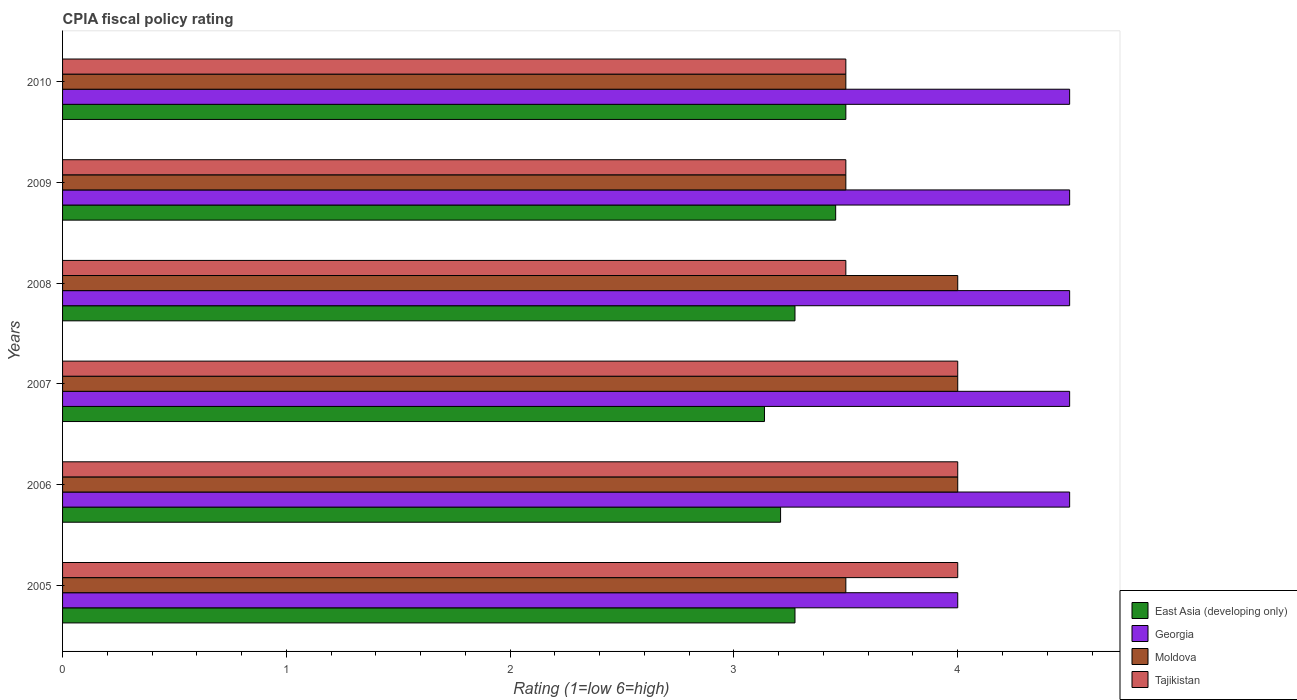Are the number of bars per tick equal to the number of legend labels?
Offer a very short reply. Yes. What is the CPIA rating in Moldova in 2010?
Offer a very short reply. 3.5. In which year was the CPIA rating in Tajikistan maximum?
Your answer should be compact. 2005. In which year was the CPIA rating in Georgia minimum?
Provide a short and direct response. 2005. What is the difference between the CPIA rating in Georgia in 2007 and that in 2010?
Offer a very short reply. 0. What is the average CPIA rating in Moldova per year?
Ensure brevity in your answer.  3.75. In the year 2007, what is the difference between the CPIA rating in Moldova and CPIA rating in Tajikistan?
Keep it short and to the point. 0. In how many years, is the CPIA rating in Tajikistan greater than 0.8 ?
Offer a very short reply. 6. Is the CPIA rating in Tajikistan in 2006 less than that in 2007?
Your answer should be very brief. No. Is the difference between the CPIA rating in Moldova in 2008 and 2010 greater than the difference between the CPIA rating in Tajikistan in 2008 and 2010?
Ensure brevity in your answer.  Yes. What is the difference between the highest and the lowest CPIA rating in Georgia?
Offer a terse response. 0.5. In how many years, is the CPIA rating in East Asia (developing only) greater than the average CPIA rating in East Asia (developing only) taken over all years?
Provide a short and direct response. 2. What does the 4th bar from the top in 2008 represents?
Provide a short and direct response. East Asia (developing only). What does the 4th bar from the bottom in 2010 represents?
Provide a succinct answer. Tajikistan. What is the difference between two consecutive major ticks on the X-axis?
Offer a terse response. 1. How many legend labels are there?
Give a very brief answer. 4. What is the title of the graph?
Give a very brief answer. CPIA fiscal policy rating. What is the Rating (1=low 6=high) of East Asia (developing only) in 2005?
Your response must be concise. 3.27. What is the Rating (1=low 6=high) in Georgia in 2005?
Provide a succinct answer. 4. What is the Rating (1=low 6=high) of Moldova in 2005?
Provide a succinct answer. 3.5. What is the Rating (1=low 6=high) in East Asia (developing only) in 2006?
Your answer should be compact. 3.21. What is the Rating (1=low 6=high) of Georgia in 2006?
Keep it short and to the point. 4.5. What is the Rating (1=low 6=high) in Moldova in 2006?
Offer a terse response. 4. What is the Rating (1=low 6=high) of East Asia (developing only) in 2007?
Give a very brief answer. 3.14. What is the Rating (1=low 6=high) of Georgia in 2007?
Provide a short and direct response. 4.5. What is the Rating (1=low 6=high) of East Asia (developing only) in 2008?
Give a very brief answer. 3.27. What is the Rating (1=low 6=high) in Tajikistan in 2008?
Offer a very short reply. 3.5. What is the Rating (1=low 6=high) in East Asia (developing only) in 2009?
Provide a short and direct response. 3.45. What is the Rating (1=low 6=high) of Moldova in 2009?
Your answer should be compact. 3.5. What is the Rating (1=low 6=high) in Tajikistan in 2009?
Your answer should be very brief. 3.5. What is the Rating (1=low 6=high) in East Asia (developing only) in 2010?
Your response must be concise. 3.5. What is the Rating (1=low 6=high) in Georgia in 2010?
Ensure brevity in your answer.  4.5. Across all years, what is the maximum Rating (1=low 6=high) of East Asia (developing only)?
Make the answer very short. 3.5. Across all years, what is the maximum Rating (1=low 6=high) of Georgia?
Offer a terse response. 4.5. Across all years, what is the maximum Rating (1=low 6=high) in Moldova?
Your response must be concise. 4. Across all years, what is the minimum Rating (1=low 6=high) in East Asia (developing only)?
Make the answer very short. 3.14. Across all years, what is the minimum Rating (1=low 6=high) in Georgia?
Keep it short and to the point. 4. Across all years, what is the minimum Rating (1=low 6=high) in Moldova?
Make the answer very short. 3.5. Across all years, what is the minimum Rating (1=low 6=high) of Tajikistan?
Keep it short and to the point. 3.5. What is the total Rating (1=low 6=high) in East Asia (developing only) in the graph?
Your answer should be compact. 19.84. What is the total Rating (1=low 6=high) in Georgia in the graph?
Offer a very short reply. 26.5. What is the total Rating (1=low 6=high) of Tajikistan in the graph?
Your answer should be compact. 22.5. What is the difference between the Rating (1=low 6=high) of East Asia (developing only) in 2005 and that in 2006?
Your answer should be compact. 0.06. What is the difference between the Rating (1=low 6=high) of Georgia in 2005 and that in 2006?
Offer a very short reply. -0.5. What is the difference between the Rating (1=low 6=high) of East Asia (developing only) in 2005 and that in 2007?
Give a very brief answer. 0.14. What is the difference between the Rating (1=low 6=high) in East Asia (developing only) in 2005 and that in 2008?
Your answer should be very brief. 0. What is the difference between the Rating (1=low 6=high) of Georgia in 2005 and that in 2008?
Your answer should be compact. -0.5. What is the difference between the Rating (1=low 6=high) in Moldova in 2005 and that in 2008?
Keep it short and to the point. -0.5. What is the difference between the Rating (1=low 6=high) of Tajikistan in 2005 and that in 2008?
Give a very brief answer. 0.5. What is the difference between the Rating (1=low 6=high) in East Asia (developing only) in 2005 and that in 2009?
Offer a very short reply. -0.18. What is the difference between the Rating (1=low 6=high) in Moldova in 2005 and that in 2009?
Offer a very short reply. 0. What is the difference between the Rating (1=low 6=high) of East Asia (developing only) in 2005 and that in 2010?
Offer a terse response. -0.23. What is the difference between the Rating (1=low 6=high) in Moldova in 2005 and that in 2010?
Your response must be concise. 0. What is the difference between the Rating (1=low 6=high) of Tajikistan in 2005 and that in 2010?
Your response must be concise. 0.5. What is the difference between the Rating (1=low 6=high) of East Asia (developing only) in 2006 and that in 2007?
Ensure brevity in your answer.  0.07. What is the difference between the Rating (1=low 6=high) of Moldova in 2006 and that in 2007?
Ensure brevity in your answer.  0. What is the difference between the Rating (1=low 6=high) in Tajikistan in 2006 and that in 2007?
Give a very brief answer. 0. What is the difference between the Rating (1=low 6=high) in East Asia (developing only) in 2006 and that in 2008?
Provide a succinct answer. -0.06. What is the difference between the Rating (1=low 6=high) of Georgia in 2006 and that in 2008?
Offer a terse response. 0. What is the difference between the Rating (1=low 6=high) of East Asia (developing only) in 2006 and that in 2009?
Keep it short and to the point. -0.25. What is the difference between the Rating (1=low 6=high) in East Asia (developing only) in 2006 and that in 2010?
Your answer should be compact. -0.29. What is the difference between the Rating (1=low 6=high) of Tajikistan in 2006 and that in 2010?
Offer a terse response. 0.5. What is the difference between the Rating (1=low 6=high) of East Asia (developing only) in 2007 and that in 2008?
Offer a terse response. -0.14. What is the difference between the Rating (1=low 6=high) of Moldova in 2007 and that in 2008?
Make the answer very short. 0. What is the difference between the Rating (1=low 6=high) in East Asia (developing only) in 2007 and that in 2009?
Offer a very short reply. -0.32. What is the difference between the Rating (1=low 6=high) in Tajikistan in 2007 and that in 2009?
Your answer should be very brief. 0.5. What is the difference between the Rating (1=low 6=high) in East Asia (developing only) in 2007 and that in 2010?
Your answer should be very brief. -0.36. What is the difference between the Rating (1=low 6=high) of Georgia in 2007 and that in 2010?
Give a very brief answer. 0. What is the difference between the Rating (1=low 6=high) in Tajikistan in 2007 and that in 2010?
Make the answer very short. 0.5. What is the difference between the Rating (1=low 6=high) of East Asia (developing only) in 2008 and that in 2009?
Your answer should be compact. -0.18. What is the difference between the Rating (1=low 6=high) of Georgia in 2008 and that in 2009?
Provide a short and direct response. 0. What is the difference between the Rating (1=low 6=high) of Moldova in 2008 and that in 2009?
Keep it short and to the point. 0.5. What is the difference between the Rating (1=low 6=high) of East Asia (developing only) in 2008 and that in 2010?
Offer a very short reply. -0.23. What is the difference between the Rating (1=low 6=high) of Moldova in 2008 and that in 2010?
Make the answer very short. 0.5. What is the difference between the Rating (1=low 6=high) of Tajikistan in 2008 and that in 2010?
Offer a very short reply. 0. What is the difference between the Rating (1=low 6=high) of East Asia (developing only) in 2009 and that in 2010?
Your response must be concise. -0.05. What is the difference between the Rating (1=low 6=high) of Georgia in 2009 and that in 2010?
Provide a succinct answer. 0. What is the difference between the Rating (1=low 6=high) in Tajikistan in 2009 and that in 2010?
Provide a short and direct response. 0. What is the difference between the Rating (1=low 6=high) in East Asia (developing only) in 2005 and the Rating (1=low 6=high) in Georgia in 2006?
Ensure brevity in your answer.  -1.23. What is the difference between the Rating (1=low 6=high) in East Asia (developing only) in 2005 and the Rating (1=low 6=high) in Moldova in 2006?
Give a very brief answer. -0.73. What is the difference between the Rating (1=low 6=high) in East Asia (developing only) in 2005 and the Rating (1=low 6=high) in Tajikistan in 2006?
Ensure brevity in your answer.  -0.73. What is the difference between the Rating (1=low 6=high) of Georgia in 2005 and the Rating (1=low 6=high) of Tajikistan in 2006?
Ensure brevity in your answer.  0. What is the difference between the Rating (1=low 6=high) of Moldova in 2005 and the Rating (1=low 6=high) of Tajikistan in 2006?
Your answer should be very brief. -0.5. What is the difference between the Rating (1=low 6=high) in East Asia (developing only) in 2005 and the Rating (1=low 6=high) in Georgia in 2007?
Your response must be concise. -1.23. What is the difference between the Rating (1=low 6=high) of East Asia (developing only) in 2005 and the Rating (1=low 6=high) of Moldova in 2007?
Your answer should be very brief. -0.73. What is the difference between the Rating (1=low 6=high) of East Asia (developing only) in 2005 and the Rating (1=low 6=high) of Tajikistan in 2007?
Offer a terse response. -0.73. What is the difference between the Rating (1=low 6=high) of East Asia (developing only) in 2005 and the Rating (1=low 6=high) of Georgia in 2008?
Offer a terse response. -1.23. What is the difference between the Rating (1=low 6=high) of East Asia (developing only) in 2005 and the Rating (1=low 6=high) of Moldova in 2008?
Your answer should be compact. -0.73. What is the difference between the Rating (1=low 6=high) of East Asia (developing only) in 2005 and the Rating (1=low 6=high) of Tajikistan in 2008?
Your response must be concise. -0.23. What is the difference between the Rating (1=low 6=high) in Georgia in 2005 and the Rating (1=low 6=high) in Moldova in 2008?
Give a very brief answer. 0. What is the difference between the Rating (1=low 6=high) of Moldova in 2005 and the Rating (1=low 6=high) of Tajikistan in 2008?
Provide a succinct answer. 0. What is the difference between the Rating (1=low 6=high) in East Asia (developing only) in 2005 and the Rating (1=low 6=high) in Georgia in 2009?
Provide a succinct answer. -1.23. What is the difference between the Rating (1=low 6=high) in East Asia (developing only) in 2005 and the Rating (1=low 6=high) in Moldova in 2009?
Offer a very short reply. -0.23. What is the difference between the Rating (1=low 6=high) in East Asia (developing only) in 2005 and the Rating (1=low 6=high) in Tajikistan in 2009?
Your answer should be compact. -0.23. What is the difference between the Rating (1=low 6=high) in Georgia in 2005 and the Rating (1=low 6=high) in Tajikistan in 2009?
Ensure brevity in your answer.  0.5. What is the difference between the Rating (1=low 6=high) of Moldova in 2005 and the Rating (1=low 6=high) of Tajikistan in 2009?
Offer a very short reply. 0. What is the difference between the Rating (1=low 6=high) of East Asia (developing only) in 2005 and the Rating (1=low 6=high) of Georgia in 2010?
Your answer should be very brief. -1.23. What is the difference between the Rating (1=low 6=high) of East Asia (developing only) in 2005 and the Rating (1=low 6=high) of Moldova in 2010?
Your response must be concise. -0.23. What is the difference between the Rating (1=low 6=high) of East Asia (developing only) in 2005 and the Rating (1=low 6=high) of Tajikistan in 2010?
Make the answer very short. -0.23. What is the difference between the Rating (1=low 6=high) of Georgia in 2005 and the Rating (1=low 6=high) of Moldova in 2010?
Provide a short and direct response. 0.5. What is the difference between the Rating (1=low 6=high) of East Asia (developing only) in 2006 and the Rating (1=low 6=high) of Georgia in 2007?
Make the answer very short. -1.29. What is the difference between the Rating (1=low 6=high) of East Asia (developing only) in 2006 and the Rating (1=low 6=high) of Moldova in 2007?
Give a very brief answer. -0.79. What is the difference between the Rating (1=low 6=high) in East Asia (developing only) in 2006 and the Rating (1=low 6=high) in Tajikistan in 2007?
Give a very brief answer. -0.79. What is the difference between the Rating (1=low 6=high) in Georgia in 2006 and the Rating (1=low 6=high) in Tajikistan in 2007?
Your answer should be very brief. 0.5. What is the difference between the Rating (1=low 6=high) in Moldova in 2006 and the Rating (1=low 6=high) in Tajikistan in 2007?
Offer a very short reply. 0. What is the difference between the Rating (1=low 6=high) in East Asia (developing only) in 2006 and the Rating (1=low 6=high) in Georgia in 2008?
Give a very brief answer. -1.29. What is the difference between the Rating (1=low 6=high) of East Asia (developing only) in 2006 and the Rating (1=low 6=high) of Moldova in 2008?
Offer a very short reply. -0.79. What is the difference between the Rating (1=low 6=high) in East Asia (developing only) in 2006 and the Rating (1=low 6=high) in Tajikistan in 2008?
Provide a succinct answer. -0.29. What is the difference between the Rating (1=low 6=high) of Georgia in 2006 and the Rating (1=low 6=high) of Tajikistan in 2008?
Provide a succinct answer. 1. What is the difference between the Rating (1=low 6=high) of Moldova in 2006 and the Rating (1=low 6=high) of Tajikistan in 2008?
Offer a very short reply. 0.5. What is the difference between the Rating (1=low 6=high) in East Asia (developing only) in 2006 and the Rating (1=low 6=high) in Georgia in 2009?
Your answer should be compact. -1.29. What is the difference between the Rating (1=low 6=high) in East Asia (developing only) in 2006 and the Rating (1=low 6=high) in Moldova in 2009?
Keep it short and to the point. -0.29. What is the difference between the Rating (1=low 6=high) in East Asia (developing only) in 2006 and the Rating (1=low 6=high) in Tajikistan in 2009?
Provide a succinct answer. -0.29. What is the difference between the Rating (1=low 6=high) of Moldova in 2006 and the Rating (1=low 6=high) of Tajikistan in 2009?
Your answer should be very brief. 0.5. What is the difference between the Rating (1=low 6=high) of East Asia (developing only) in 2006 and the Rating (1=low 6=high) of Georgia in 2010?
Provide a short and direct response. -1.29. What is the difference between the Rating (1=low 6=high) in East Asia (developing only) in 2006 and the Rating (1=low 6=high) in Moldova in 2010?
Your response must be concise. -0.29. What is the difference between the Rating (1=low 6=high) of East Asia (developing only) in 2006 and the Rating (1=low 6=high) of Tajikistan in 2010?
Your answer should be compact. -0.29. What is the difference between the Rating (1=low 6=high) in Georgia in 2006 and the Rating (1=low 6=high) in Moldova in 2010?
Your response must be concise. 1. What is the difference between the Rating (1=low 6=high) in Georgia in 2006 and the Rating (1=low 6=high) in Tajikistan in 2010?
Offer a very short reply. 1. What is the difference between the Rating (1=low 6=high) of Moldova in 2006 and the Rating (1=low 6=high) of Tajikistan in 2010?
Provide a succinct answer. 0.5. What is the difference between the Rating (1=low 6=high) in East Asia (developing only) in 2007 and the Rating (1=low 6=high) in Georgia in 2008?
Offer a very short reply. -1.36. What is the difference between the Rating (1=low 6=high) in East Asia (developing only) in 2007 and the Rating (1=low 6=high) in Moldova in 2008?
Offer a very short reply. -0.86. What is the difference between the Rating (1=low 6=high) in East Asia (developing only) in 2007 and the Rating (1=low 6=high) in Tajikistan in 2008?
Provide a succinct answer. -0.36. What is the difference between the Rating (1=low 6=high) of Moldova in 2007 and the Rating (1=low 6=high) of Tajikistan in 2008?
Provide a short and direct response. 0.5. What is the difference between the Rating (1=low 6=high) of East Asia (developing only) in 2007 and the Rating (1=low 6=high) of Georgia in 2009?
Ensure brevity in your answer.  -1.36. What is the difference between the Rating (1=low 6=high) in East Asia (developing only) in 2007 and the Rating (1=low 6=high) in Moldova in 2009?
Make the answer very short. -0.36. What is the difference between the Rating (1=low 6=high) of East Asia (developing only) in 2007 and the Rating (1=low 6=high) of Tajikistan in 2009?
Make the answer very short. -0.36. What is the difference between the Rating (1=low 6=high) of Moldova in 2007 and the Rating (1=low 6=high) of Tajikistan in 2009?
Offer a very short reply. 0.5. What is the difference between the Rating (1=low 6=high) in East Asia (developing only) in 2007 and the Rating (1=low 6=high) in Georgia in 2010?
Your answer should be compact. -1.36. What is the difference between the Rating (1=low 6=high) of East Asia (developing only) in 2007 and the Rating (1=low 6=high) of Moldova in 2010?
Your response must be concise. -0.36. What is the difference between the Rating (1=low 6=high) in East Asia (developing only) in 2007 and the Rating (1=low 6=high) in Tajikistan in 2010?
Your answer should be compact. -0.36. What is the difference between the Rating (1=low 6=high) of East Asia (developing only) in 2008 and the Rating (1=low 6=high) of Georgia in 2009?
Give a very brief answer. -1.23. What is the difference between the Rating (1=low 6=high) in East Asia (developing only) in 2008 and the Rating (1=low 6=high) in Moldova in 2009?
Give a very brief answer. -0.23. What is the difference between the Rating (1=low 6=high) of East Asia (developing only) in 2008 and the Rating (1=low 6=high) of Tajikistan in 2009?
Make the answer very short. -0.23. What is the difference between the Rating (1=low 6=high) in Georgia in 2008 and the Rating (1=low 6=high) in Tajikistan in 2009?
Provide a short and direct response. 1. What is the difference between the Rating (1=low 6=high) in Moldova in 2008 and the Rating (1=low 6=high) in Tajikistan in 2009?
Keep it short and to the point. 0.5. What is the difference between the Rating (1=low 6=high) in East Asia (developing only) in 2008 and the Rating (1=low 6=high) in Georgia in 2010?
Offer a very short reply. -1.23. What is the difference between the Rating (1=low 6=high) in East Asia (developing only) in 2008 and the Rating (1=low 6=high) in Moldova in 2010?
Your response must be concise. -0.23. What is the difference between the Rating (1=low 6=high) in East Asia (developing only) in 2008 and the Rating (1=low 6=high) in Tajikistan in 2010?
Provide a succinct answer. -0.23. What is the difference between the Rating (1=low 6=high) of Georgia in 2008 and the Rating (1=low 6=high) of Moldova in 2010?
Give a very brief answer. 1. What is the difference between the Rating (1=low 6=high) in Georgia in 2008 and the Rating (1=low 6=high) in Tajikistan in 2010?
Offer a very short reply. 1. What is the difference between the Rating (1=low 6=high) in Moldova in 2008 and the Rating (1=low 6=high) in Tajikistan in 2010?
Give a very brief answer. 0.5. What is the difference between the Rating (1=low 6=high) of East Asia (developing only) in 2009 and the Rating (1=low 6=high) of Georgia in 2010?
Your answer should be very brief. -1.05. What is the difference between the Rating (1=low 6=high) of East Asia (developing only) in 2009 and the Rating (1=low 6=high) of Moldova in 2010?
Make the answer very short. -0.05. What is the difference between the Rating (1=low 6=high) of East Asia (developing only) in 2009 and the Rating (1=low 6=high) of Tajikistan in 2010?
Your response must be concise. -0.05. What is the difference between the Rating (1=low 6=high) of Georgia in 2009 and the Rating (1=low 6=high) of Moldova in 2010?
Your response must be concise. 1. What is the difference between the Rating (1=low 6=high) of Georgia in 2009 and the Rating (1=low 6=high) of Tajikistan in 2010?
Provide a short and direct response. 1. What is the difference between the Rating (1=low 6=high) of Moldova in 2009 and the Rating (1=low 6=high) of Tajikistan in 2010?
Keep it short and to the point. 0. What is the average Rating (1=low 6=high) of East Asia (developing only) per year?
Your answer should be compact. 3.31. What is the average Rating (1=low 6=high) in Georgia per year?
Give a very brief answer. 4.42. What is the average Rating (1=low 6=high) in Moldova per year?
Provide a short and direct response. 3.75. What is the average Rating (1=low 6=high) in Tajikistan per year?
Your answer should be very brief. 3.75. In the year 2005, what is the difference between the Rating (1=low 6=high) in East Asia (developing only) and Rating (1=low 6=high) in Georgia?
Provide a short and direct response. -0.73. In the year 2005, what is the difference between the Rating (1=low 6=high) in East Asia (developing only) and Rating (1=low 6=high) in Moldova?
Your answer should be very brief. -0.23. In the year 2005, what is the difference between the Rating (1=low 6=high) in East Asia (developing only) and Rating (1=low 6=high) in Tajikistan?
Provide a short and direct response. -0.73. In the year 2005, what is the difference between the Rating (1=low 6=high) in Georgia and Rating (1=low 6=high) in Moldova?
Your answer should be very brief. 0.5. In the year 2005, what is the difference between the Rating (1=low 6=high) of Georgia and Rating (1=low 6=high) of Tajikistan?
Provide a short and direct response. 0. In the year 2006, what is the difference between the Rating (1=low 6=high) of East Asia (developing only) and Rating (1=low 6=high) of Georgia?
Offer a very short reply. -1.29. In the year 2006, what is the difference between the Rating (1=low 6=high) in East Asia (developing only) and Rating (1=low 6=high) in Moldova?
Your response must be concise. -0.79. In the year 2006, what is the difference between the Rating (1=low 6=high) in East Asia (developing only) and Rating (1=low 6=high) in Tajikistan?
Ensure brevity in your answer.  -0.79. In the year 2006, what is the difference between the Rating (1=low 6=high) of Georgia and Rating (1=low 6=high) of Moldova?
Your answer should be compact. 0.5. In the year 2006, what is the difference between the Rating (1=low 6=high) in Moldova and Rating (1=low 6=high) in Tajikistan?
Your answer should be very brief. 0. In the year 2007, what is the difference between the Rating (1=low 6=high) in East Asia (developing only) and Rating (1=low 6=high) in Georgia?
Give a very brief answer. -1.36. In the year 2007, what is the difference between the Rating (1=low 6=high) of East Asia (developing only) and Rating (1=low 6=high) of Moldova?
Provide a succinct answer. -0.86. In the year 2007, what is the difference between the Rating (1=low 6=high) of East Asia (developing only) and Rating (1=low 6=high) of Tajikistan?
Keep it short and to the point. -0.86. In the year 2007, what is the difference between the Rating (1=low 6=high) in Georgia and Rating (1=low 6=high) in Moldova?
Your answer should be very brief. 0.5. In the year 2008, what is the difference between the Rating (1=low 6=high) of East Asia (developing only) and Rating (1=low 6=high) of Georgia?
Your answer should be compact. -1.23. In the year 2008, what is the difference between the Rating (1=low 6=high) of East Asia (developing only) and Rating (1=low 6=high) of Moldova?
Provide a short and direct response. -0.73. In the year 2008, what is the difference between the Rating (1=low 6=high) in East Asia (developing only) and Rating (1=low 6=high) in Tajikistan?
Give a very brief answer. -0.23. In the year 2009, what is the difference between the Rating (1=low 6=high) of East Asia (developing only) and Rating (1=low 6=high) of Georgia?
Make the answer very short. -1.05. In the year 2009, what is the difference between the Rating (1=low 6=high) in East Asia (developing only) and Rating (1=low 6=high) in Moldova?
Your answer should be very brief. -0.05. In the year 2009, what is the difference between the Rating (1=low 6=high) in East Asia (developing only) and Rating (1=low 6=high) in Tajikistan?
Offer a very short reply. -0.05. In the year 2009, what is the difference between the Rating (1=low 6=high) of Georgia and Rating (1=low 6=high) of Tajikistan?
Your response must be concise. 1. In the year 2010, what is the difference between the Rating (1=low 6=high) of East Asia (developing only) and Rating (1=low 6=high) of Georgia?
Offer a very short reply. -1. In the year 2010, what is the difference between the Rating (1=low 6=high) in East Asia (developing only) and Rating (1=low 6=high) in Tajikistan?
Offer a very short reply. 0. In the year 2010, what is the difference between the Rating (1=low 6=high) in Georgia and Rating (1=low 6=high) in Moldova?
Offer a very short reply. 1. What is the ratio of the Rating (1=low 6=high) of East Asia (developing only) in 2005 to that in 2006?
Give a very brief answer. 1.02. What is the ratio of the Rating (1=low 6=high) in East Asia (developing only) in 2005 to that in 2007?
Your response must be concise. 1.04. What is the ratio of the Rating (1=low 6=high) in Georgia in 2005 to that in 2007?
Keep it short and to the point. 0.89. What is the ratio of the Rating (1=low 6=high) in Moldova in 2005 to that in 2007?
Offer a terse response. 0.88. What is the ratio of the Rating (1=low 6=high) of Tajikistan in 2005 to that in 2007?
Your answer should be compact. 1. What is the ratio of the Rating (1=low 6=high) of Georgia in 2005 to that in 2008?
Your response must be concise. 0.89. What is the ratio of the Rating (1=low 6=high) of Tajikistan in 2005 to that in 2008?
Ensure brevity in your answer.  1.14. What is the ratio of the Rating (1=low 6=high) of East Asia (developing only) in 2005 to that in 2009?
Your response must be concise. 0.95. What is the ratio of the Rating (1=low 6=high) in East Asia (developing only) in 2005 to that in 2010?
Provide a short and direct response. 0.94. What is the ratio of the Rating (1=low 6=high) of Georgia in 2005 to that in 2010?
Make the answer very short. 0.89. What is the ratio of the Rating (1=low 6=high) of Tajikistan in 2005 to that in 2010?
Offer a terse response. 1.14. What is the ratio of the Rating (1=low 6=high) of East Asia (developing only) in 2006 to that in 2007?
Keep it short and to the point. 1.02. What is the ratio of the Rating (1=low 6=high) of Tajikistan in 2006 to that in 2007?
Ensure brevity in your answer.  1. What is the ratio of the Rating (1=low 6=high) in East Asia (developing only) in 2006 to that in 2008?
Your answer should be compact. 0.98. What is the ratio of the Rating (1=low 6=high) of East Asia (developing only) in 2006 to that in 2009?
Keep it short and to the point. 0.93. What is the ratio of the Rating (1=low 6=high) in East Asia (developing only) in 2006 to that in 2010?
Give a very brief answer. 0.92. What is the ratio of the Rating (1=low 6=high) in Moldova in 2006 to that in 2010?
Your answer should be very brief. 1.14. What is the ratio of the Rating (1=low 6=high) in Tajikistan in 2006 to that in 2010?
Offer a very short reply. 1.14. What is the ratio of the Rating (1=low 6=high) of Georgia in 2007 to that in 2008?
Give a very brief answer. 1. What is the ratio of the Rating (1=low 6=high) of East Asia (developing only) in 2007 to that in 2009?
Ensure brevity in your answer.  0.91. What is the ratio of the Rating (1=low 6=high) in Georgia in 2007 to that in 2009?
Offer a terse response. 1. What is the ratio of the Rating (1=low 6=high) of Tajikistan in 2007 to that in 2009?
Provide a short and direct response. 1.14. What is the ratio of the Rating (1=low 6=high) of East Asia (developing only) in 2007 to that in 2010?
Give a very brief answer. 0.9. What is the ratio of the Rating (1=low 6=high) in East Asia (developing only) in 2008 to that in 2009?
Your response must be concise. 0.95. What is the ratio of the Rating (1=low 6=high) of Tajikistan in 2008 to that in 2009?
Make the answer very short. 1. What is the ratio of the Rating (1=low 6=high) of East Asia (developing only) in 2008 to that in 2010?
Your answer should be compact. 0.94. What is the ratio of the Rating (1=low 6=high) in Georgia in 2008 to that in 2010?
Give a very brief answer. 1. What is the ratio of the Rating (1=low 6=high) in Tajikistan in 2008 to that in 2010?
Offer a terse response. 1. What is the difference between the highest and the second highest Rating (1=low 6=high) of East Asia (developing only)?
Provide a succinct answer. 0.05. What is the difference between the highest and the lowest Rating (1=low 6=high) of East Asia (developing only)?
Offer a terse response. 0.36. What is the difference between the highest and the lowest Rating (1=low 6=high) of Georgia?
Your answer should be very brief. 0.5. What is the difference between the highest and the lowest Rating (1=low 6=high) of Moldova?
Your answer should be very brief. 0.5. What is the difference between the highest and the lowest Rating (1=low 6=high) of Tajikistan?
Offer a terse response. 0.5. 